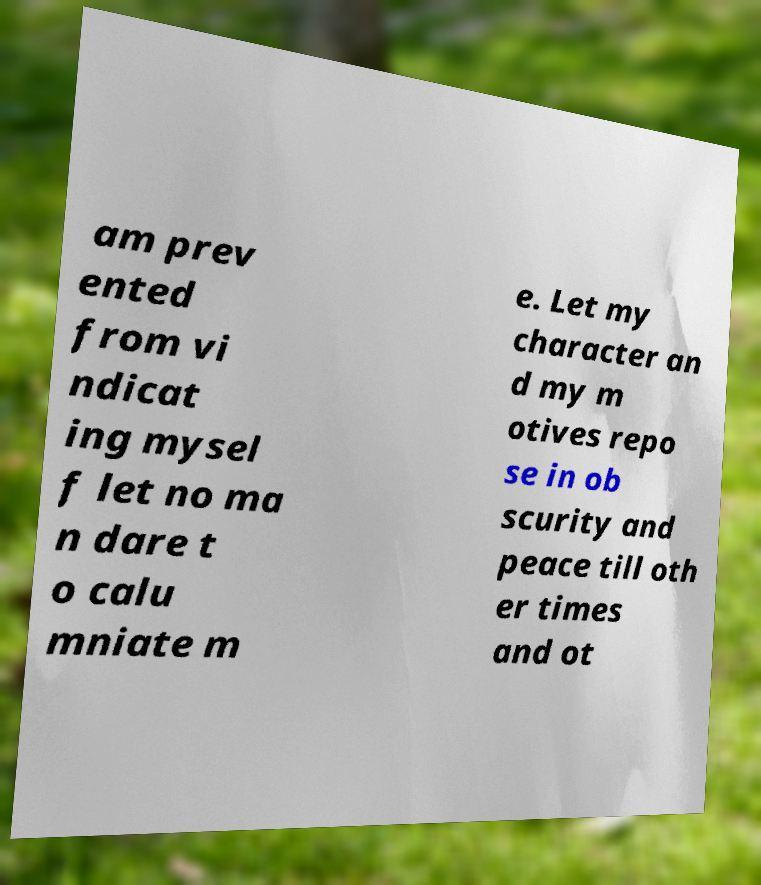Please identify and transcribe the text found in this image. am prev ented from vi ndicat ing mysel f let no ma n dare t o calu mniate m e. Let my character an d my m otives repo se in ob scurity and peace till oth er times and ot 